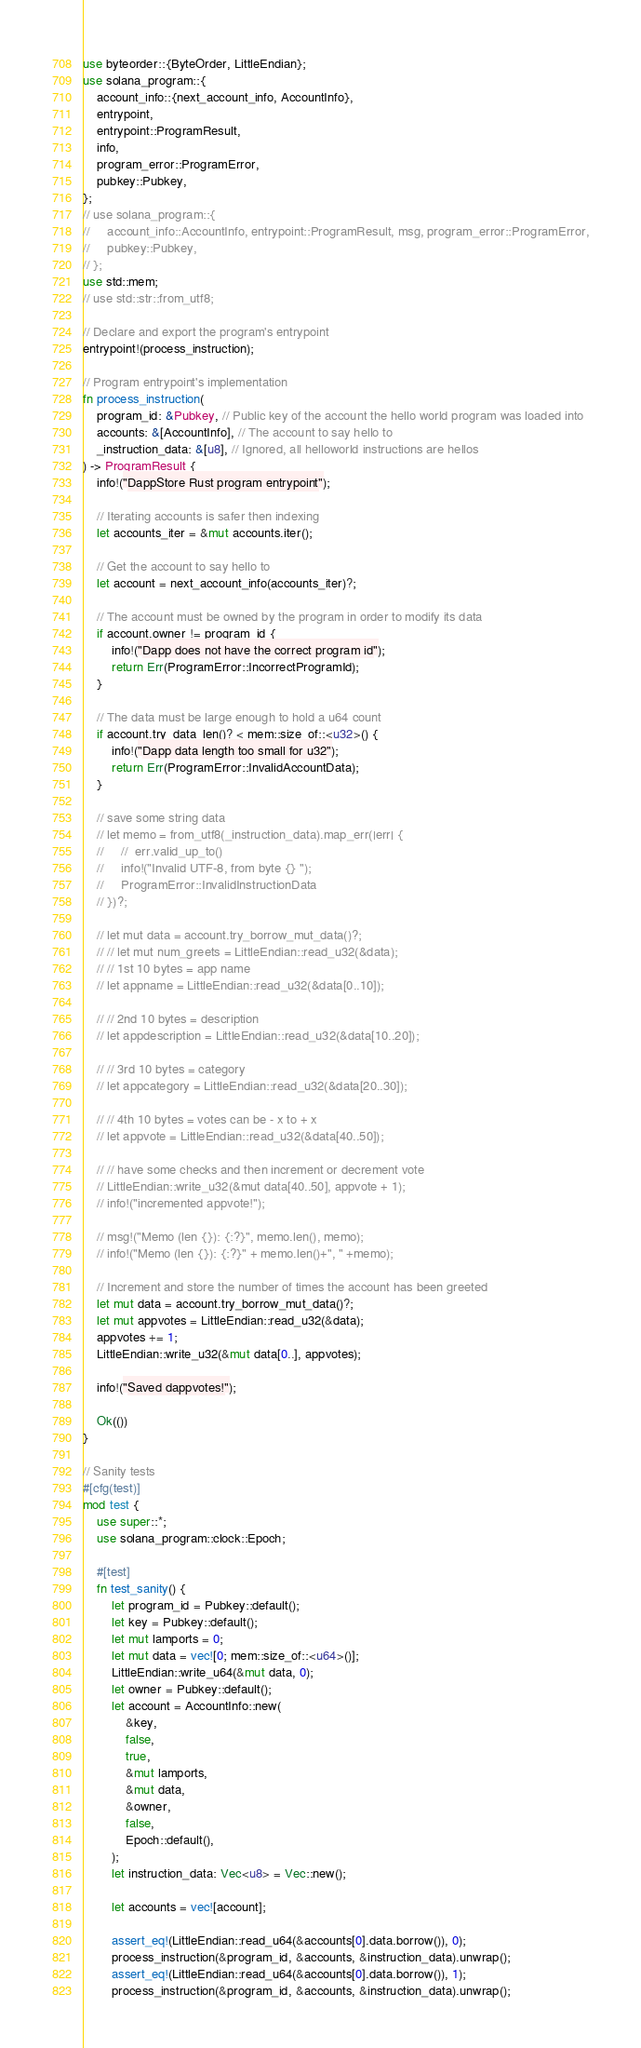<code> <loc_0><loc_0><loc_500><loc_500><_Rust_>use byteorder::{ByteOrder, LittleEndian};
use solana_program::{
    account_info::{next_account_info, AccountInfo},
    entrypoint,
    entrypoint::ProgramResult,
    info,
    program_error::ProgramError,
    pubkey::Pubkey,
};
// use solana_program::{
//     account_info::AccountInfo, entrypoint::ProgramResult, msg, program_error::ProgramError,
//     pubkey::Pubkey,
// };
use std::mem;
// use std::str::from_utf8;

// Declare and export the program's entrypoint
entrypoint!(process_instruction);

// Program entrypoint's implementation
fn process_instruction(
    program_id: &Pubkey, // Public key of the account the hello world program was loaded into
    accounts: &[AccountInfo], // The account to say hello to
    _instruction_data: &[u8], // Ignored, all helloworld instructions are hellos
) -> ProgramResult {
    info!("DappStore Rust program entrypoint");

    // Iterating accounts is safer then indexing
    let accounts_iter = &mut accounts.iter();

    // Get the account to say hello to
    let account = next_account_info(accounts_iter)?;

    // The account must be owned by the program in order to modify its data
    if account.owner != program_id {
        info!("Dapp does not have the correct program id");
        return Err(ProgramError::IncorrectProgramId);
    }

    // The data must be large enough to hold a u64 count
    if account.try_data_len()? < mem::size_of::<u32>() {
        info!("Dapp data length too small for u32");
        return Err(ProgramError::InvalidAccountData);
    }

    // save some string data
    // let memo = from_utf8(_instruction_data).map_err(|err| {
    //     //  err.valid_up_to()
    //     info!("Invalid UTF-8, from byte {} ");
    //     ProgramError::InvalidInstructionData
    // })?;

    // let mut data = account.try_borrow_mut_data()?;
    // // let mut num_greets = LittleEndian::read_u32(&data);
    // // 1st 10 bytes = app name
    // let appname = LittleEndian::read_u32(&data[0..10]);

    // // 2nd 10 bytes = description
    // let appdescription = LittleEndian::read_u32(&data[10..20]);

    // // 3rd 10 bytes = category
    // let appcategory = LittleEndian::read_u32(&data[20..30]);

    // // 4th 10 bytes = votes can be - x to + x
    // let appvote = LittleEndian::read_u32(&data[40..50]);

    // // have some checks and then increment or decrement vote
    // LittleEndian::write_u32(&mut data[40..50], appvote + 1);
    // info!("incremented appvote!");

    // msg!("Memo (len {}): {:?}", memo.len(), memo);
    // info!("Memo (len {}): {:?}" + memo.len()+", " +memo);

    // Increment and store the number of times the account has been greeted
    let mut data = account.try_borrow_mut_data()?;
    let mut appvotes = LittleEndian::read_u32(&data);
    appvotes += 1;
    LittleEndian::write_u32(&mut data[0..], appvotes);

    info!("Saved dappvotes!");

    Ok(())
}

// Sanity tests
#[cfg(test)]
mod test {
    use super::*;
    use solana_program::clock::Epoch;

    #[test]
    fn test_sanity() {
        let program_id = Pubkey::default();
        let key = Pubkey::default();
        let mut lamports = 0;
        let mut data = vec![0; mem::size_of::<u64>()];
        LittleEndian::write_u64(&mut data, 0);
        let owner = Pubkey::default();
        let account = AccountInfo::new(
            &key,
            false,
            true,
            &mut lamports,
            &mut data,
            &owner,
            false,
            Epoch::default(),
        );
        let instruction_data: Vec<u8> = Vec::new();

        let accounts = vec![account];

        assert_eq!(LittleEndian::read_u64(&accounts[0].data.borrow()), 0);
        process_instruction(&program_id, &accounts, &instruction_data).unwrap();
        assert_eq!(LittleEndian::read_u64(&accounts[0].data.borrow()), 1);
        process_instruction(&program_id, &accounts, &instruction_data).unwrap();</code> 